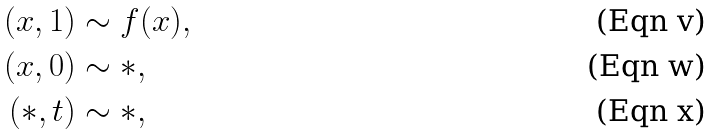Convert formula to latex. <formula><loc_0><loc_0><loc_500><loc_500>( x , 1 ) & \sim f ( x ) , \\ ( x , 0 ) & \sim \ast , \\ ( \ast , t ) & \sim \ast ,</formula> 